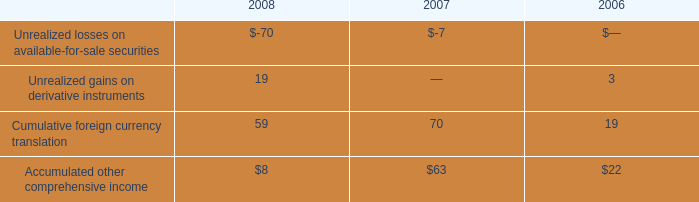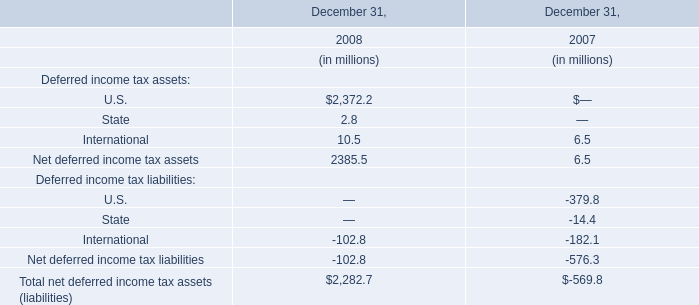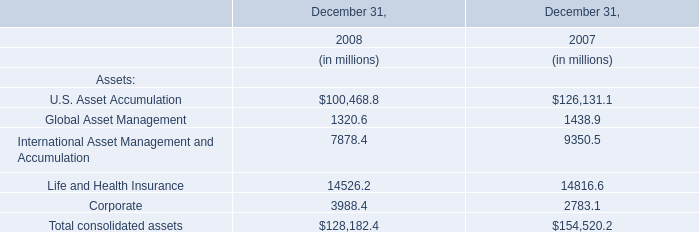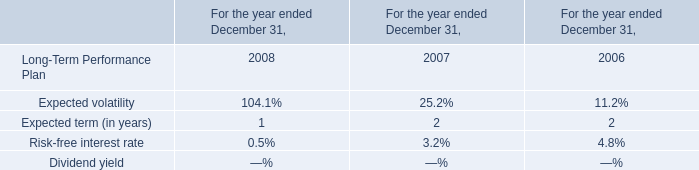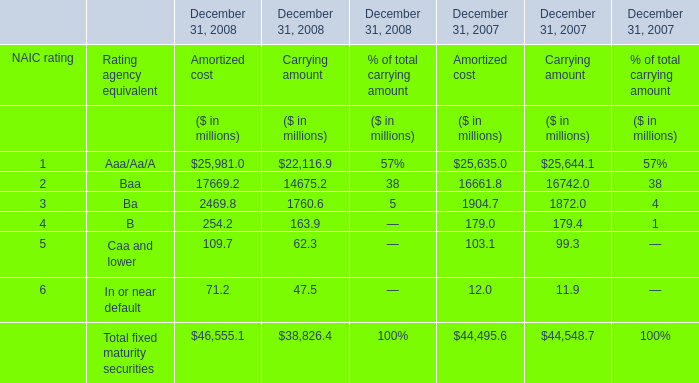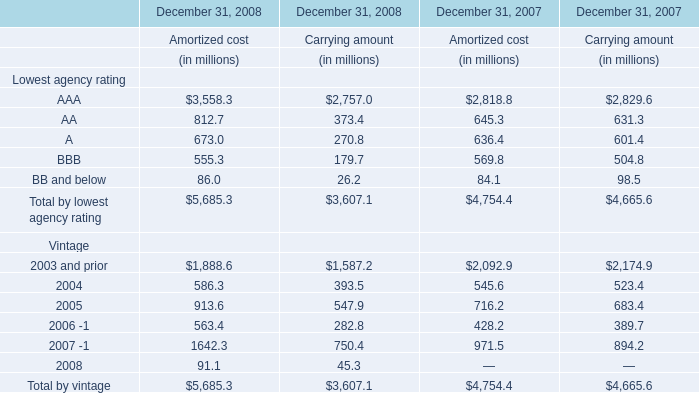What's the average of U.S. Asset Accumulation of December 31, 2007, and 2.0 of December 31, 2007 Amortized cost ? 
Computations: ((126131.1 + 16661.8) / 2)
Answer: 71396.45. 